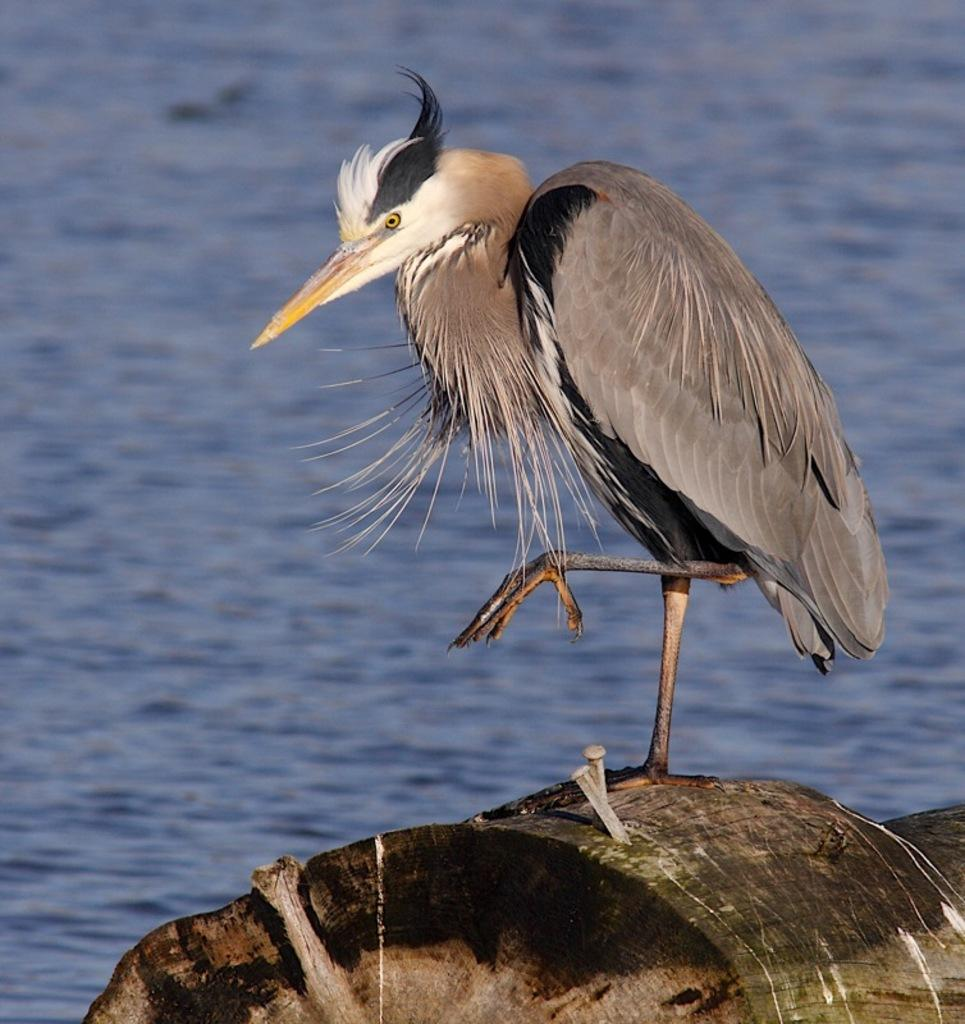What type of animal can be seen in the image? There is a bird in the image. Where is the bird located in the image? The bird is on a wooden object. What natural element is visible in the image? There is water visible in the image. How many balls are being transported by the bird in the image? There are no balls or any indication of transportation in the image; it features a bird on a wooden object with water visible. What type of quiver is the bird holding in the image? There is no quiver present in the image; it features a bird on a wooden object with water visible. 